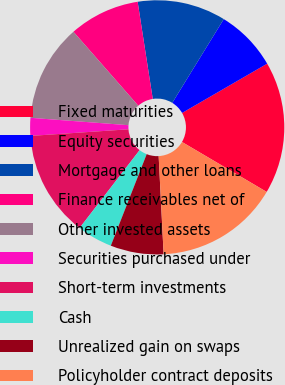<chart> <loc_0><loc_0><loc_500><loc_500><pie_chart><fcel>Fixed maturities<fcel>Equity securities<fcel>Mortgage and other loans<fcel>Finance receivables net of<fcel>Other invested assets<fcel>Securities purchased under<fcel>Short-term investments<fcel>Cash<fcel>Unrealized gain on swaps<fcel>Policyholder contract deposits<nl><fcel>16.83%<fcel>7.87%<fcel>11.23%<fcel>8.99%<fcel>12.35%<fcel>2.27%<fcel>13.47%<fcel>4.51%<fcel>6.75%<fcel>15.71%<nl></chart> 